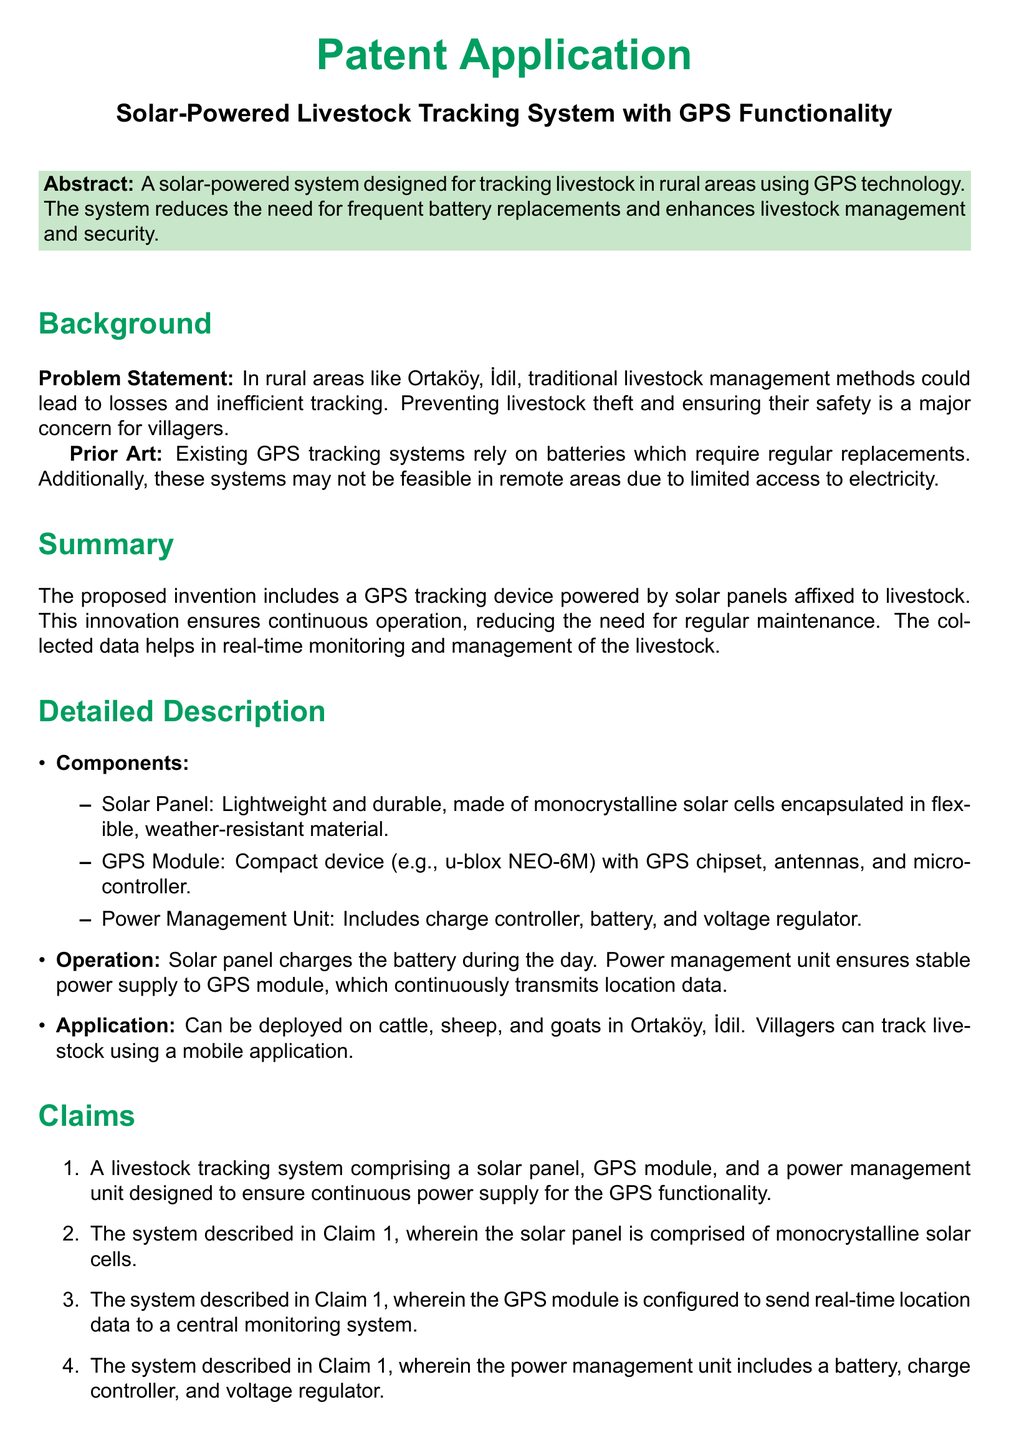What is the title of the patent application? The title of the patent application is specified at the beginning of the document.
Answer: Solar-Powered Livestock Tracking System with GPS Functionality What problem does the invention aim to address? The problem statement outlines the major concern in rural areas that the invention seeks to solve.
Answer: Livestock theft and inefficient tracking What is the primary power source for the GPS tracking device? The detailed description section mentions the primary power source of the tracking device.
Answer: Solar panels What type of solar cells are used in the solar panel? The claims detail the specific type of solar cells incorporated in the system.
Answer: Monocrystalline solar cells What animals can the tracking system be deployed on? The application section lists the types of livestock suitable for this tracking system.
Answer: Cattle, sheep, and goats What component ensures a stable power supply to the GPS module? The detailed description specifies the function of a particular component regarding power supply stability.
Answer: Power Management Unit How does the system benefit remote areas? The advantages section provides reasoning on the system's benefits specifically for remote locations.
Answer: Reduces the need for battery replacements Which module sends real-time location data? The claims section indicates the functionality of a specific module related to tracking data transmission.
Answer: GPS module 